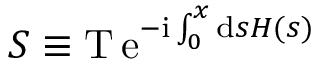Convert formula to latex. <formula><loc_0><loc_0><loc_500><loc_500>S \equiv T \, e ^ { - i \int _ { 0 } ^ { x } d s H ( s ) }</formula> 